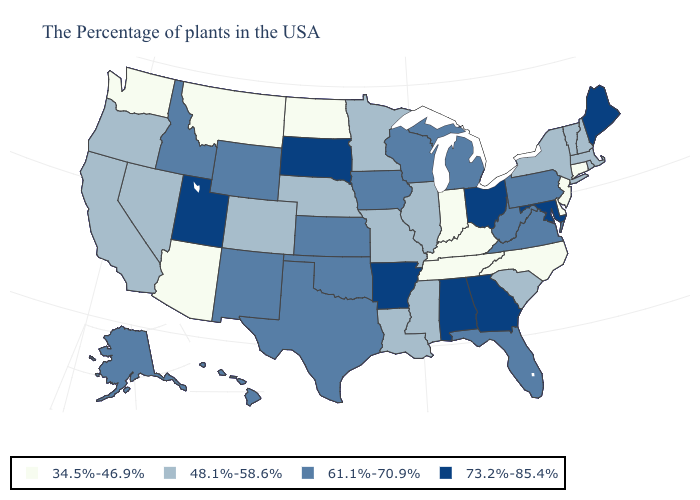Does Connecticut have the lowest value in the Northeast?
Quick response, please. Yes. What is the lowest value in states that border Minnesota?
Concise answer only. 34.5%-46.9%. Which states have the lowest value in the USA?
Keep it brief. Connecticut, New Jersey, Delaware, North Carolina, Kentucky, Indiana, Tennessee, North Dakota, Montana, Arizona, Washington. Does the first symbol in the legend represent the smallest category?
Quick response, please. Yes. Name the states that have a value in the range 61.1%-70.9%?
Write a very short answer. Pennsylvania, Virginia, West Virginia, Florida, Michigan, Wisconsin, Iowa, Kansas, Oklahoma, Texas, Wyoming, New Mexico, Idaho, Alaska, Hawaii. Which states hav the highest value in the Northeast?
Short answer required. Maine. What is the value of Vermont?
Concise answer only. 48.1%-58.6%. Does Washington have a higher value than Tennessee?
Concise answer only. No. Among the states that border Florida , which have the highest value?
Answer briefly. Georgia, Alabama. What is the value of Iowa?
Be succinct. 61.1%-70.9%. Which states have the lowest value in the USA?
Quick response, please. Connecticut, New Jersey, Delaware, North Carolina, Kentucky, Indiana, Tennessee, North Dakota, Montana, Arizona, Washington. Which states have the lowest value in the MidWest?
Quick response, please. Indiana, North Dakota. Does Wisconsin have the highest value in the MidWest?
Concise answer only. No. 